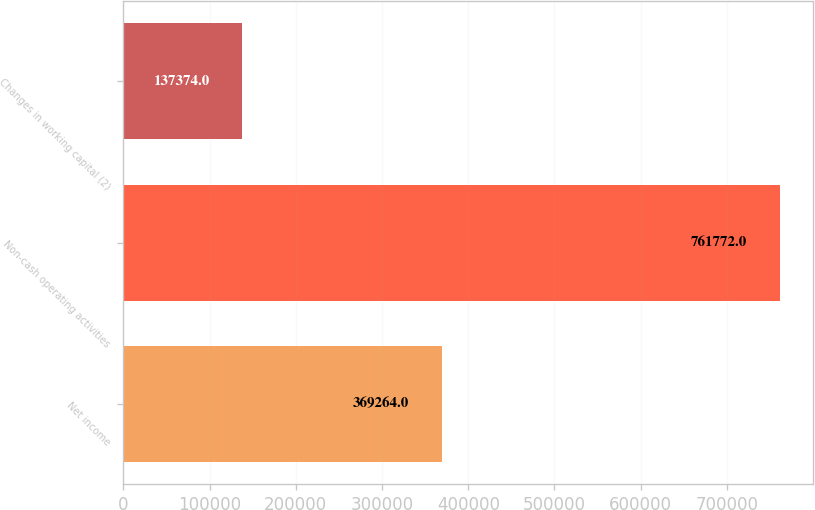<chart> <loc_0><loc_0><loc_500><loc_500><bar_chart><fcel>Net income<fcel>Non-cash operating activities<fcel>Changes in working capital (2)<nl><fcel>369264<fcel>761772<fcel>137374<nl></chart> 